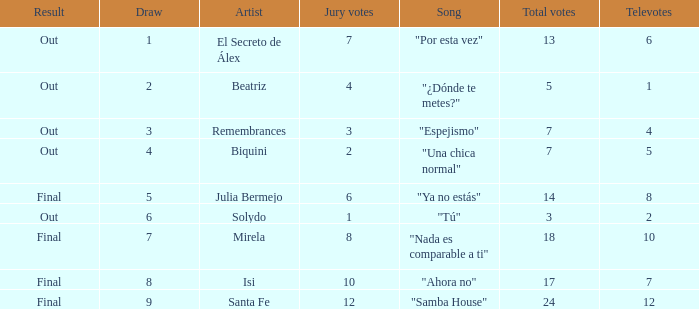Name the number of song for julia bermejo 1.0. 